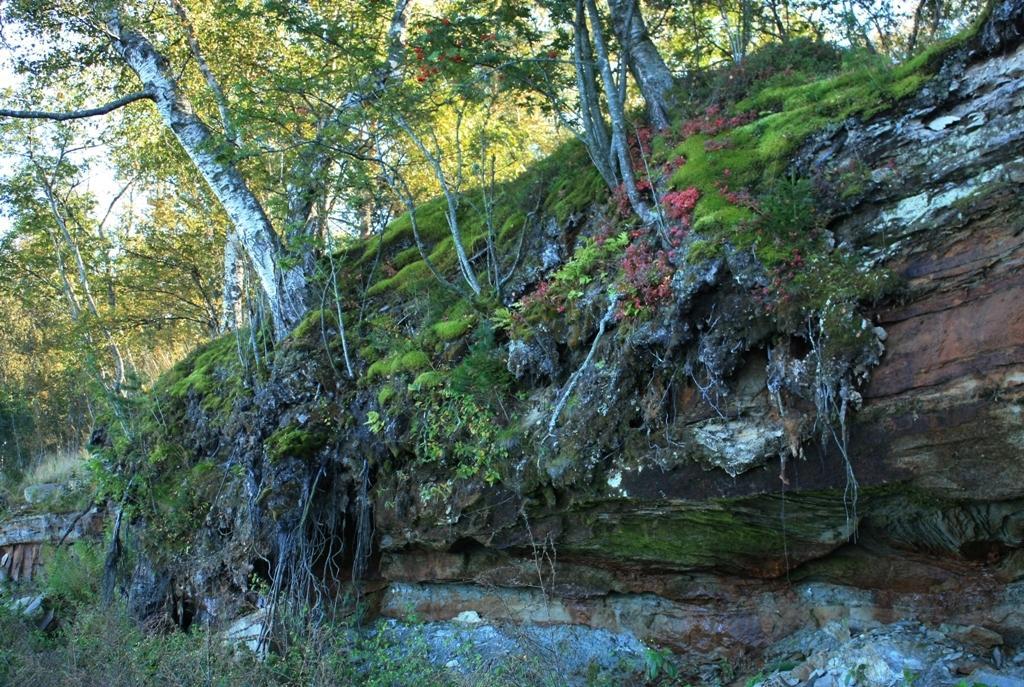How would you summarize this image in a sentence or two? In this image, we can see trees on the hill. 